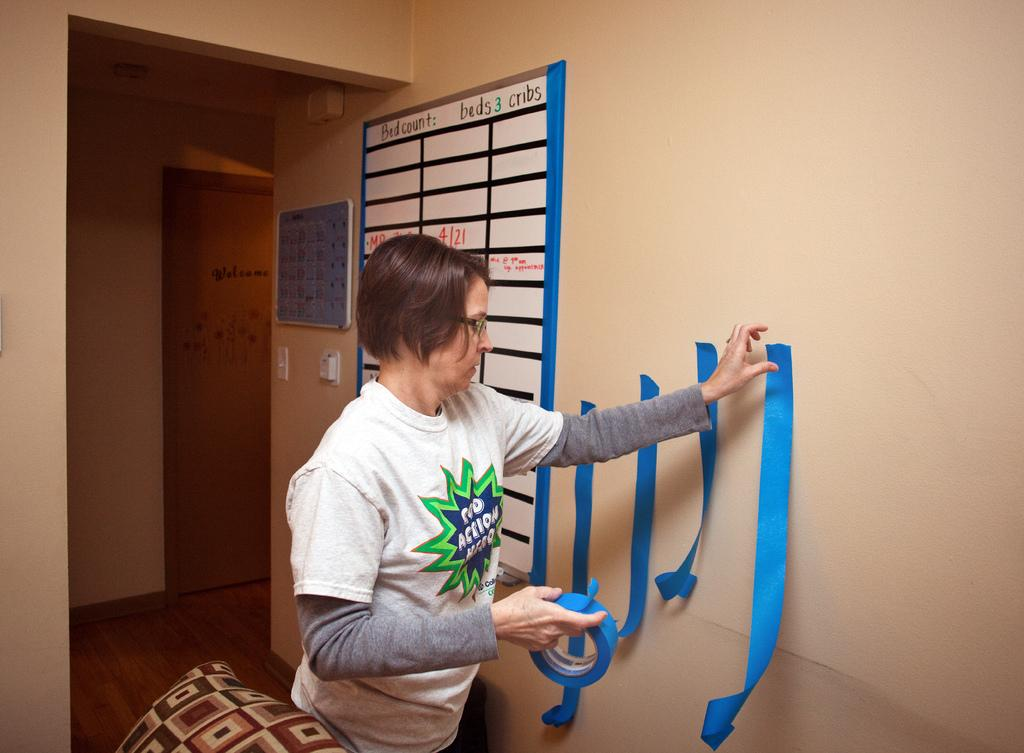Who is present in the image? There is a woman in the image. What is the woman holding in her hand? The woman is holding a tape in her hand. What can be seen on the wall in the image? There are boards and tapes on the wall. What architectural feature is visible in the background of the image? There is a door visible in the background of the image. What type of animal can be seen coughing in the image? There is no animal present in the image, and no one is coughing. 